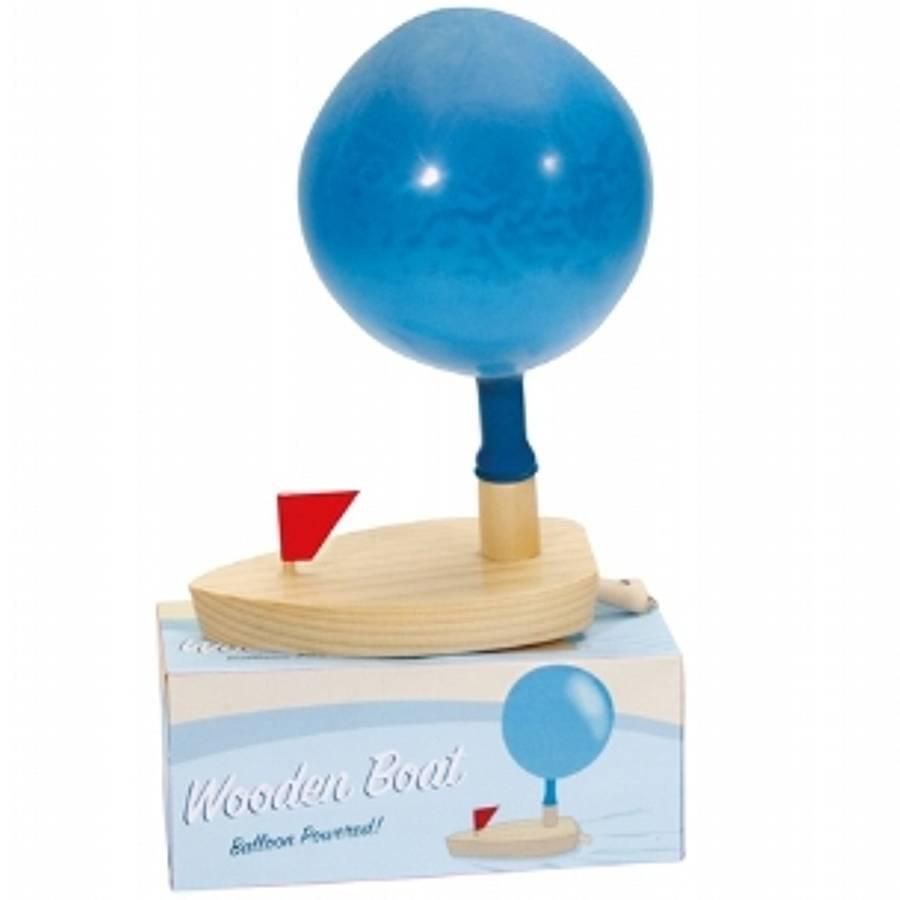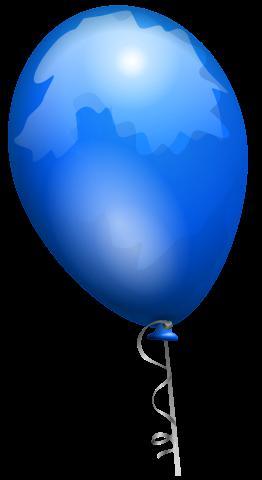The first image is the image on the left, the second image is the image on the right. Considering the images on both sides, is "One of the image has exactly four balloons." valid? Answer yes or no. No. 